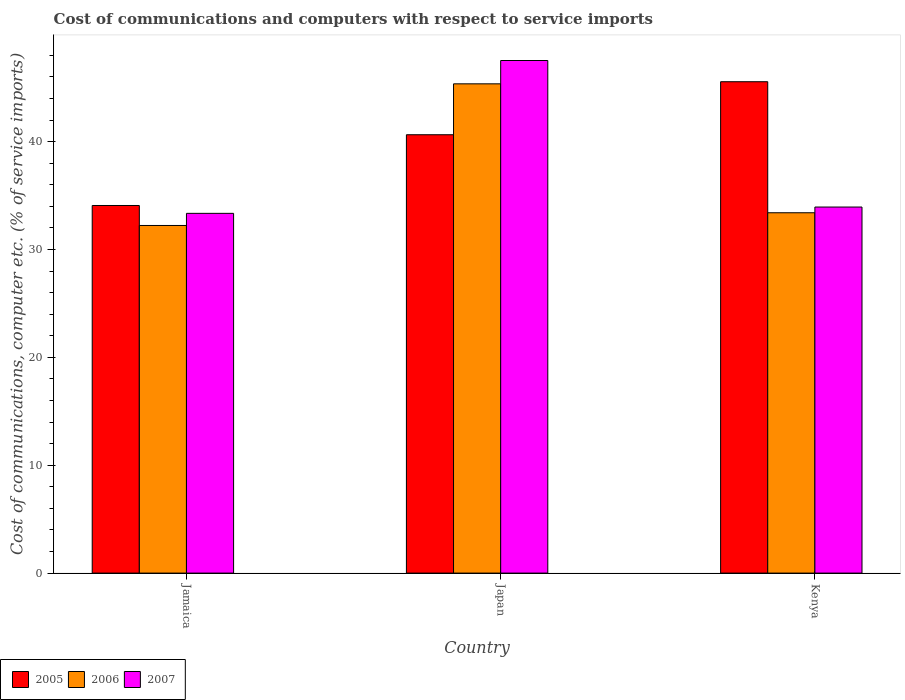How many different coloured bars are there?
Provide a short and direct response. 3. What is the label of the 1st group of bars from the left?
Provide a succinct answer. Jamaica. In how many cases, is the number of bars for a given country not equal to the number of legend labels?
Your answer should be very brief. 0. What is the cost of communications and computers in 2005 in Jamaica?
Provide a short and direct response. 34.08. Across all countries, what is the maximum cost of communications and computers in 2006?
Ensure brevity in your answer.  45.36. Across all countries, what is the minimum cost of communications and computers in 2007?
Keep it short and to the point. 33.35. In which country was the cost of communications and computers in 2005 minimum?
Provide a succinct answer. Jamaica. What is the total cost of communications and computers in 2005 in the graph?
Give a very brief answer. 120.27. What is the difference between the cost of communications and computers in 2005 in Japan and that in Kenya?
Offer a very short reply. -4.91. What is the difference between the cost of communications and computers in 2006 in Jamaica and the cost of communications and computers in 2005 in Japan?
Provide a succinct answer. -8.41. What is the average cost of communications and computers in 2007 per country?
Provide a short and direct response. 38.27. What is the difference between the cost of communications and computers of/in 2006 and cost of communications and computers of/in 2005 in Kenya?
Your answer should be very brief. -12.15. In how many countries, is the cost of communications and computers in 2007 greater than 8 %?
Ensure brevity in your answer.  3. What is the ratio of the cost of communications and computers in 2005 in Jamaica to that in Kenya?
Provide a short and direct response. 0.75. Is the cost of communications and computers in 2007 in Japan less than that in Kenya?
Offer a very short reply. No. What is the difference between the highest and the second highest cost of communications and computers in 2006?
Your answer should be compact. -1.18. What is the difference between the highest and the lowest cost of communications and computers in 2005?
Keep it short and to the point. 11.47. In how many countries, is the cost of communications and computers in 2005 greater than the average cost of communications and computers in 2005 taken over all countries?
Give a very brief answer. 2. Is it the case that in every country, the sum of the cost of communications and computers in 2006 and cost of communications and computers in 2005 is greater than the cost of communications and computers in 2007?
Provide a succinct answer. Yes. How many countries are there in the graph?
Offer a very short reply. 3. Does the graph contain any zero values?
Make the answer very short. No. Where does the legend appear in the graph?
Offer a very short reply. Bottom left. What is the title of the graph?
Ensure brevity in your answer.  Cost of communications and computers with respect to service imports. Does "2005" appear as one of the legend labels in the graph?
Keep it short and to the point. Yes. What is the label or title of the Y-axis?
Offer a very short reply. Cost of communications, computer etc. (% of service imports). What is the Cost of communications, computer etc. (% of service imports) in 2005 in Jamaica?
Give a very brief answer. 34.08. What is the Cost of communications, computer etc. (% of service imports) of 2006 in Jamaica?
Your answer should be compact. 32.23. What is the Cost of communications, computer etc. (% of service imports) in 2007 in Jamaica?
Provide a succinct answer. 33.35. What is the Cost of communications, computer etc. (% of service imports) in 2005 in Japan?
Your response must be concise. 40.64. What is the Cost of communications, computer etc. (% of service imports) of 2006 in Japan?
Give a very brief answer. 45.36. What is the Cost of communications, computer etc. (% of service imports) of 2007 in Japan?
Give a very brief answer. 47.52. What is the Cost of communications, computer etc. (% of service imports) in 2005 in Kenya?
Your answer should be compact. 45.55. What is the Cost of communications, computer etc. (% of service imports) in 2006 in Kenya?
Ensure brevity in your answer.  33.4. What is the Cost of communications, computer etc. (% of service imports) of 2007 in Kenya?
Offer a very short reply. 33.93. Across all countries, what is the maximum Cost of communications, computer etc. (% of service imports) in 2005?
Keep it short and to the point. 45.55. Across all countries, what is the maximum Cost of communications, computer etc. (% of service imports) of 2006?
Offer a very short reply. 45.36. Across all countries, what is the maximum Cost of communications, computer etc. (% of service imports) in 2007?
Offer a very short reply. 47.52. Across all countries, what is the minimum Cost of communications, computer etc. (% of service imports) of 2005?
Provide a succinct answer. 34.08. Across all countries, what is the minimum Cost of communications, computer etc. (% of service imports) in 2006?
Keep it short and to the point. 32.23. Across all countries, what is the minimum Cost of communications, computer etc. (% of service imports) of 2007?
Offer a very short reply. 33.35. What is the total Cost of communications, computer etc. (% of service imports) of 2005 in the graph?
Offer a terse response. 120.27. What is the total Cost of communications, computer etc. (% of service imports) in 2006 in the graph?
Make the answer very short. 110.98. What is the total Cost of communications, computer etc. (% of service imports) in 2007 in the graph?
Your answer should be very brief. 114.8. What is the difference between the Cost of communications, computer etc. (% of service imports) of 2005 in Jamaica and that in Japan?
Offer a very short reply. -6.56. What is the difference between the Cost of communications, computer etc. (% of service imports) in 2006 in Jamaica and that in Japan?
Your answer should be compact. -13.13. What is the difference between the Cost of communications, computer etc. (% of service imports) in 2007 in Jamaica and that in Japan?
Make the answer very short. -14.17. What is the difference between the Cost of communications, computer etc. (% of service imports) in 2005 in Jamaica and that in Kenya?
Keep it short and to the point. -11.47. What is the difference between the Cost of communications, computer etc. (% of service imports) of 2006 in Jamaica and that in Kenya?
Your answer should be compact. -1.18. What is the difference between the Cost of communications, computer etc. (% of service imports) of 2007 in Jamaica and that in Kenya?
Keep it short and to the point. -0.59. What is the difference between the Cost of communications, computer etc. (% of service imports) in 2005 in Japan and that in Kenya?
Your answer should be very brief. -4.91. What is the difference between the Cost of communications, computer etc. (% of service imports) of 2006 in Japan and that in Kenya?
Offer a terse response. 11.95. What is the difference between the Cost of communications, computer etc. (% of service imports) of 2007 in Japan and that in Kenya?
Offer a very short reply. 13.58. What is the difference between the Cost of communications, computer etc. (% of service imports) of 2005 in Jamaica and the Cost of communications, computer etc. (% of service imports) of 2006 in Japan?
Provide a succinct answer. -11.28. What is the difference between the Cost of communications, computer etc. (% of service imports) in 2005 in Jamaica and the Cost of communications, computer etc. (% of service imports) in 2007 in Japan?
Offer a very short reply. -13.44. What is the difference between the Cost of communications, computer etc. (% of service imports) in 2006 in Jamaica and the Cost of communications, computer etc. (% of service imports) in 2007 in Japan?
Give a very brief answer. -15.29. What is the difference between the Cost of communications, computer etc. (% of service imports) in 2005 in Jamaica and the Cost of communications, computer etc. (% of service imports) in 2006 in Kenya?
Your response must be concise. 0.67. What is the difference between the Cost of communications, computer etc. (% of service imports) in 2005 in Jamaica and the Cost of communications, computer etc. (% of service imports) in 2007 in Kenya?
Provide a succinct answer. 0.14. What is the difference between the Cost of communications, computer etc. (% of service imports) in 2006 in Jamaica and the Cost of communications, computer etc. (% of service imports) in 2007 in Kenya?
Your response must be concise. -1.71. What is the difference between the Cost of communications, computer etc. (% of service imports) of 2005 in Japan and the Cost of communications, computer etc. (% of service imports) of 2006 in Kenya?
Give a very brief answer. 7.23. What is the difference between the Cost of communications, computer etc. (% of service imports) in 2005 in Japan and the Cost of communications, computer etc. (% of service imports) in 2007 in Kenya?
Provide a succinct answer. 6.7. What is the difference between the Cost of communications, computer etc. (% of service imports) in 2006 in Japan and the Cost of communications, computer etc. (% of service imports) in 2007 in Kenya?
Your response must be concise. 11.42. What is the average Cost of communications, computer etc. (% of service imports) of 2005 per country?
Your answer should be compact. 40.09. What is the average Cost of communications, computer etc. (% of service imports) in 2006 per country?
Make the answer very short. 36.99. What is the average Cost of communications, computer etc. (% of service imports) in 2007 per country?
Provide a succinct answer. 38.27. What is the difference between the Cost of communications, computer etc. (% of service imports) of 2005 and Cost of communications, computer etc. (% of service imports) of 2006 in Jamaica?
Provide a short and direct response. 1.85. What is the difference between the Cost of communications, computer etc. (% of service imports) in 2005 and Cost of communications, computer etc. (% of service imports) in 2007 in Jamaica?
Provide a short and direct response. 0.73. What is the difference between the Cost of communications, computer etc. (% of service imports) in 2006 and Cost of communications, computer etc. (% of service imports) in 2007 in Jamaica?
Provide a short and direct response. -1.12. What is the difference between the Cost of communications, computer etc. (% of service imports) in 2005 and Cost of communications, computer etc. (% of service imports) in 2006 in Japan?
Provide a short and direct response. -4.72. What is the difference between the Cost of communications, computer etc. (% of service imports) of 2005 and Cost of communications, computer etc. (% of service imports) of 2007 in Japan?
Offer a terse response. -6.88. What is the difference between the Cost of communications, computer etc. (% of service imports) of 2006 and Cost of communications, computer etc. (% of service imports) of 2007 in Japan?
Provide a short and direct response. -2.16. What is the difference between the Cost of communications, computer etc. (% of service imports) in 2005 and Cost of communications, computer etc. (% of service imports) in 2006 in Kenya?
Offer a terse response. 12.15. What is the difference between the Cost of communications, computer etc. (% of service imports) of 2005 and Cost of communications, computer etc. (% of service imports) of 2007 in Kenya?
Ensure brevity in your answer.  11.62. What is the difference between the Cost of communications, computer etc. (% of service imports) of 2006 and Cost of communications, computer etc. (% of service imports) of 2007 in Kenya?
Give a very brief answer. -0.53. What is the ratio of the Cost of communications, computer etc. (% of service imports) in 2005 in Jamaica to that in Japan?
Provide a short and direct response. 0.84. What is the ratio of the Cost of communications, computer etc. (% of service imports) of 2006 in Jamaica to that in Japan?
Your answer should be very brief. 0.71. What is the ratio of the Cost of communications, computer etc. (% of service imports) in 2007 in Jamaica to that in Japan?
Keep it short and to the point. 0.7. What is the ratio of the Cost of communications, computer etc. (% of service imports) in 2005 in Jamaica to that in Kenya?
Your answer should be compact. 0.75. What is the ratio of the Cost of communications, computer etc. (% of service imports) of 2006 in Jamaica to that in Kenya?
Provide a succinct answer. 0.96. What is the ratio of the Cost of communications, computer etc. (% of service imports) of 2007 in Jamaica to that in Kenya?
Give a very brief answer. 0.98. What is the ratio of the Cost of communications, computer etc. (% of service imports) of 2005 in Japan to that in Kenya?
Ensure brevity in your answer.  0.89. What is the ratio of the Cost of communications, computer etc. (% of service imports) in 2006 in Japan to that in Kenya?
Keep it short and to the point. 1.36. What is the ratio of the Cost of communications, computer etc. (% of service imports) in 2007 in Japan to that in Kenya?
Provide a succinct answer. 1.4. What is the difference between the highest and the second highest Cost of communications, computer etc. (% of service imports) of 2005?
Your answer should be very brief. 4.91. What is the difference between the highest and the second highest Cost of communications, computer etc. (% of service imports) of 2006?
Provide a short and direct response. 11.95. What is the difference between the highest and the second highest Cost of communications, computer etc. (% of service imports) in 2007?
Your answer should be very brief. 13.58. What is the difference between the highest and the lowest Cost of communications, computer etc. (% of service imports) of 2005?
Keep it short and to the point. 11.47. What is the difference between the highest and the lowest Cost of communications, computer etc. (% of service imports) in 2006?
Keep it short and to the point. 13.13. What is the difference between the highest and the lowest Cost of communications, computer etc. (% of service imports) of 2007?
Provide a succinct answer. 14.17. 